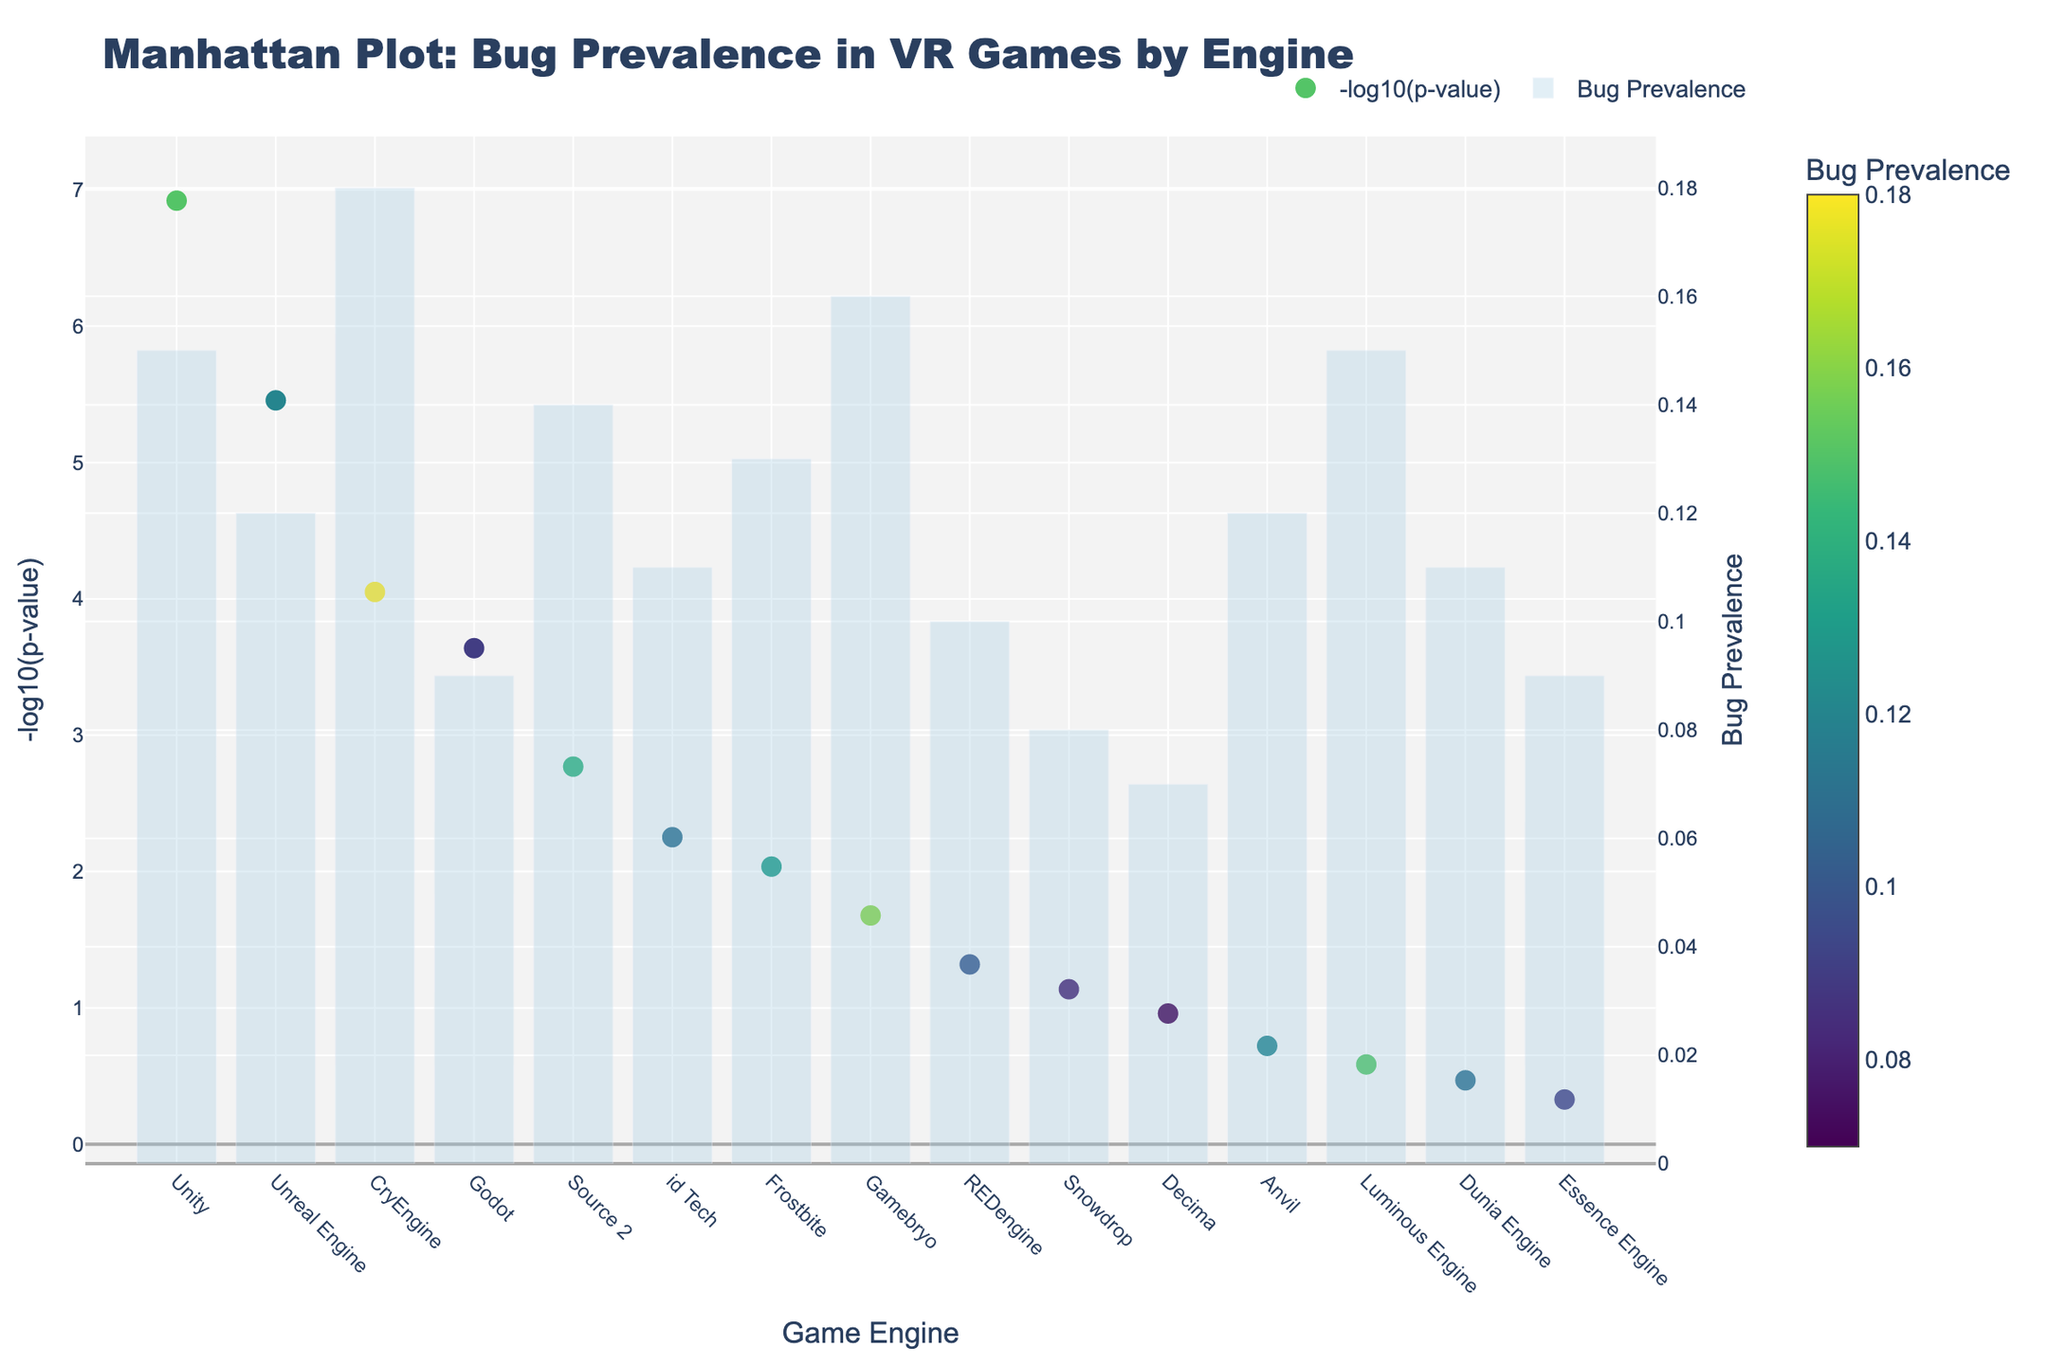what is the title of the plot? The title is usually located at the top of the plot and it often directly describes the main topic or data visualized. On the provided Manhattan Plot, the title reads "Manhattan Plot: Bug Prevalence in VR Games by Engine".
Answer: Manhattan Plot: Bug Prevalence in VR Games by Engine what color is used to represent the Bug Prevalence? The color scale representing the Bug Prevalence is shown as a color bar, which uses a colorscale named 'Viridis'. The colors range from bright green to dark purple.
Answer: Viridis colorscale which game engine has the highest bug prevalence? Looking at the bar height on the secondary y-axis (right side), the highest bar corresponds to the game engine "CryEngine", which has a Bug Prevalence of 0.18.
Answer: CryEngine which game engine has the smallest -log10(p-value)? The smallest -log10(p-value) can be identified by finding the marker closest to zero on the left y-axis. This corresponds to "Essence Engine".
Answer: Essence Engine how many game engines have a -log10(p-value) greater than 2? Counting the markers above the horizontal line representing 2 on the left y-axis shows three game engines "Unity", "Unreal Engine", and "CryEngine".
Answer: 3 what is the median bug prevalence across all game engines? To find the median, sort the Bug Prevalence values (0.07, 0.08, 0.09, 0.09, 0.10, 0.11, 0.11, 0.12, 0.12, 0.13, 0.14, 0.15, 0.15, 0.16, 0.18). The middle value (8th value in sorted order) is 0.12.
Answer: 0.12 compare the -log10(p-value)s of Unity and Decima. Which one is higher? Comparing the heights of the markers for Unity and Decima on the left y-axis, Unity's marker is much higher than Decima's. Hence, Unity has a higher -log10(p-value).
Answer: Unity which game engines have an identical bug prevalence? Looking at the bar heights, "Godot" and "Essence Engine" both have a bug prevalence of 0.09. Similarly, "Unity" and "Luminous Engine" both have a bug prevalence of 0.15.
Answer: Godot & Essence Engine, Unity & Luminous Engine what is the average -log10(p-value) of the first three game engines with the highest bug prevalence? The first three highest bug prevalences belong to CryEngine (0.18), Gamebryo (0.16), and Unity (0.15). Their -log10(p-values) are 4.05 (-log10(8.9e-5)), 1.68 (-log10(2.1e-2)), and 6.92 (-log10(1.2e-7)), respectively. The average is (4.05 + 1.68 + 6.92) / 3 = 4.2167.
Answer: 4.22 